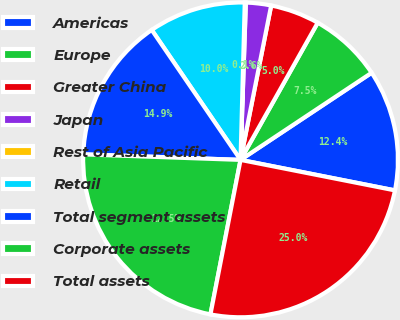Convert chart. <chart><loc_0><loc_0><loc_500><loc_500><pie_chart><fcel>Americas<fcel>Europe<fcel>Greater China<fcel>Japan<fcel>Rest of Asia Pacific<fcel>Retail<fcel>Total segment assets<fcel>Corporate assets<fcel>Total assets<nl><fcel>12.44%<fcel>7.51%<fcel>5.04%<fcel>2.58%<fcel>0.11%<fcel>9.97%<fcel>14.9%<fcel>22.5%<fcel>24.96%<nl></chart> 